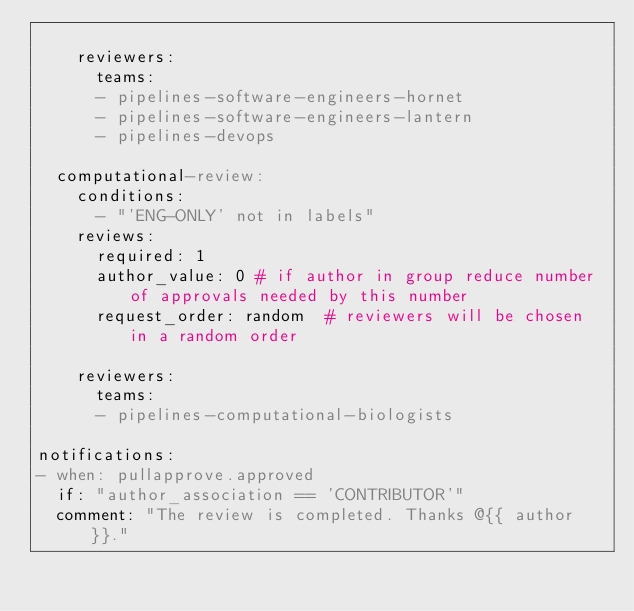Convert code to text. <code><loc_0><loc_0><loc_500><loc_500><_YAML_>
    reviewers:
      teams:
      - pipelines-software-engineers-hornet
      - pipelines-software-engineers-lantern
      - pipelines-devops

  computational-review:
    conditions:
      - "'ENG-ONLY' not in labels"
    reviews:
      required: 1
      author_value: 0 # if author in group reduce number of approvals needed by this number
      request_order: random  # reviewers will be chosen in a random order

    reviewers:
      teams:
      - pipelines-computational-biologists

notifications:
- when: pullapprove.approved
  if: "author_association == 'CONTRIBUTOR'"
  comment: "The review is completed. Thanks @{{ author }}."
</code> 